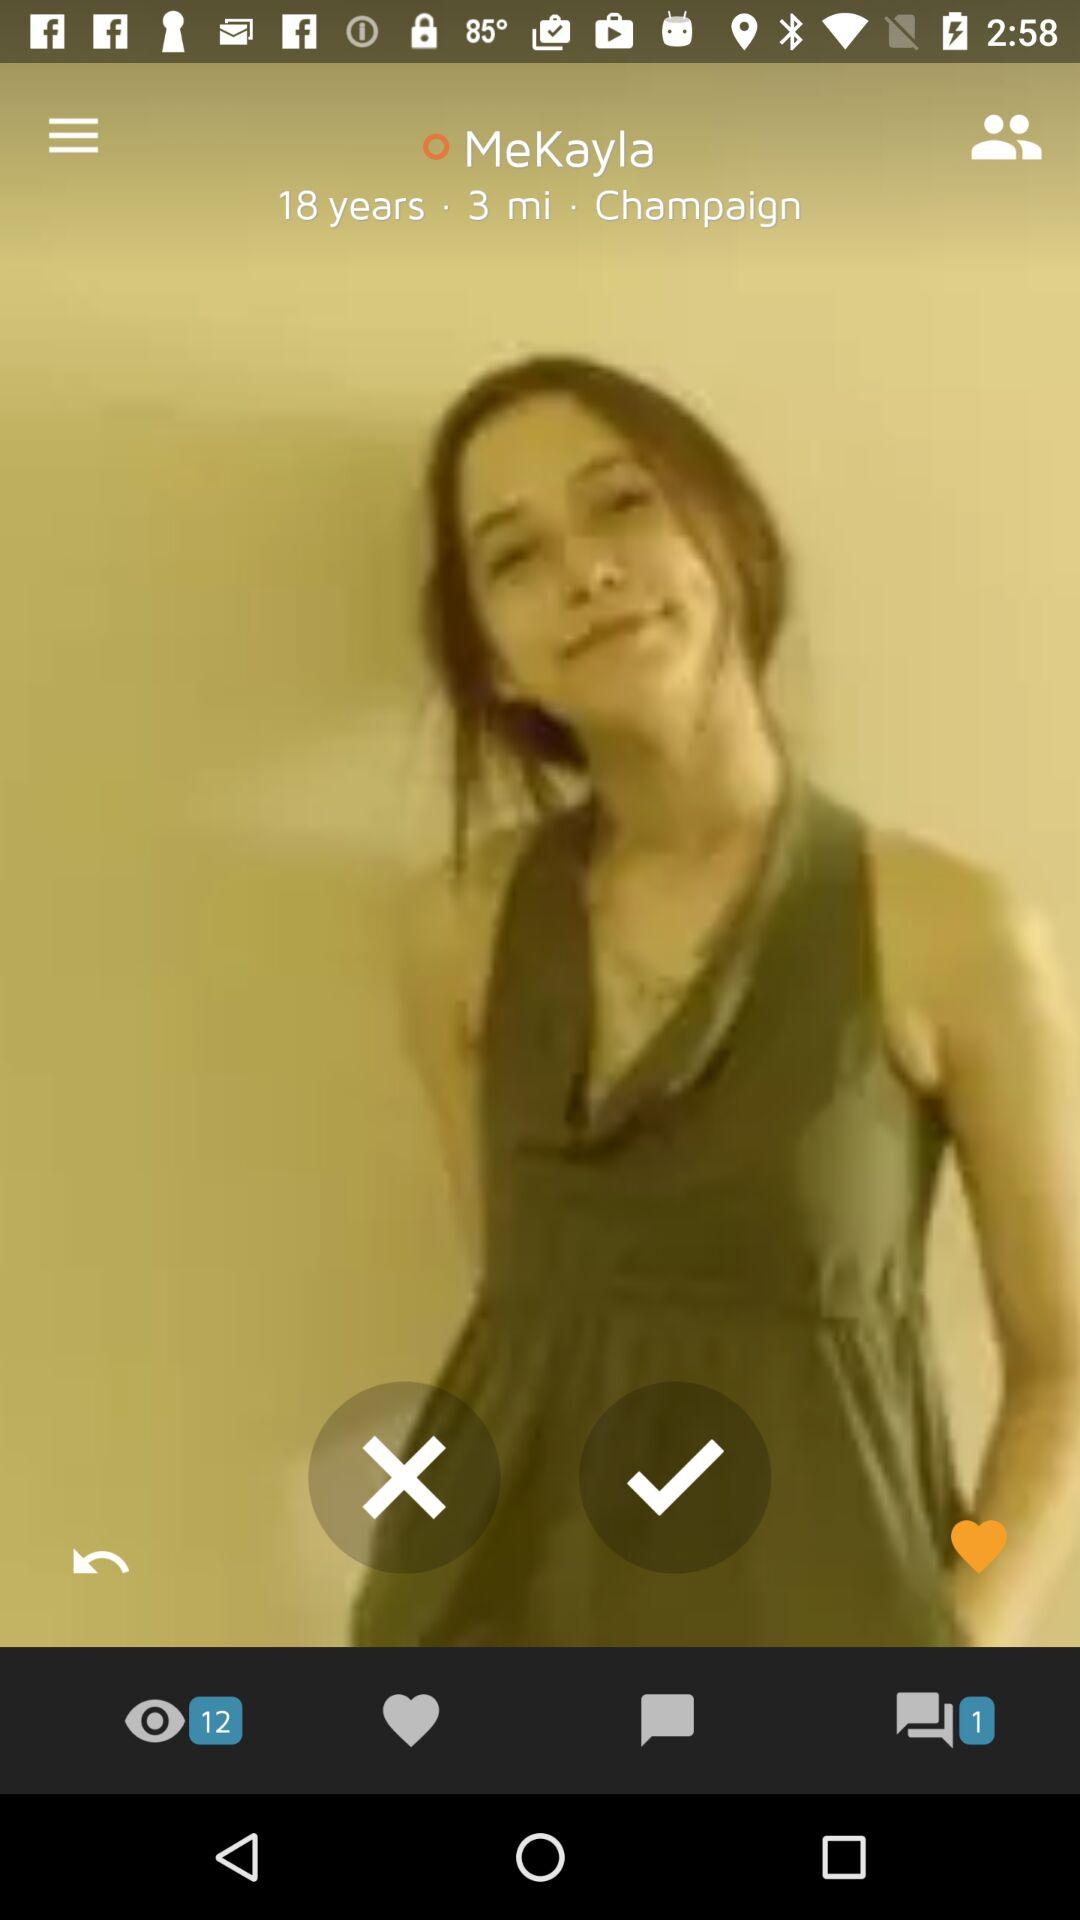What is the age? The age is 18 years old. 